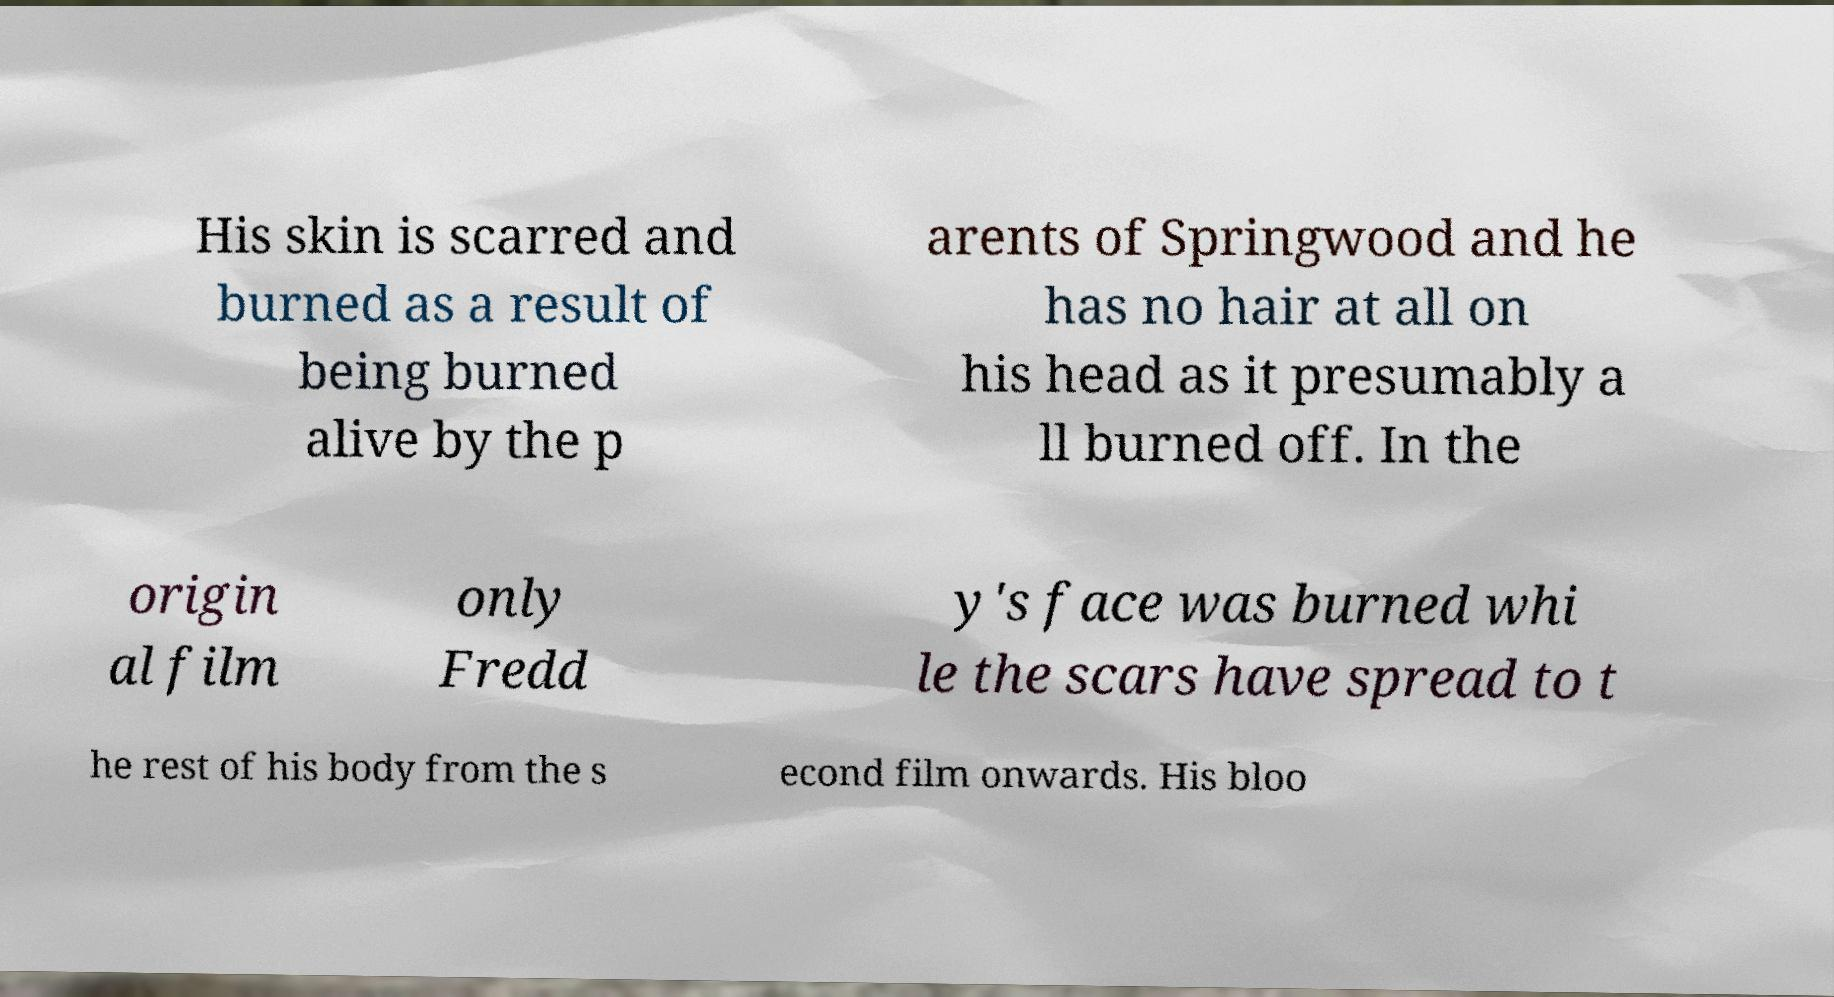Could you extract and type out the text from this image? His skin is scarred and burned as a result of being burned alive by the p arents of Springwood and he has no hair at all on his head as it presumably a ll burned off. In the origin al film only Fredd y's face was burned whi le the scars have spread to t he rest of his body from the s econd film onwards. His bloo 